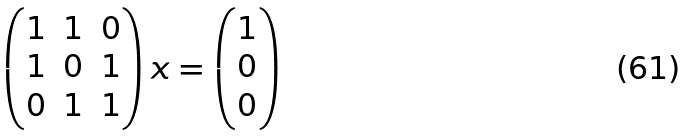Convert formula to latex. <formula><loc_0><loc_0><loc_500><loc_500>\begin{pmatrix} 1 & 1 & 0 \\ 1 & 0 & 1 \\ 0 & 1 & 1 \\ \end{pmatrix} x = \begin{pmatrix} 1 \\ 0 \\ 0 \\ \end{pmatrix}</formula> 